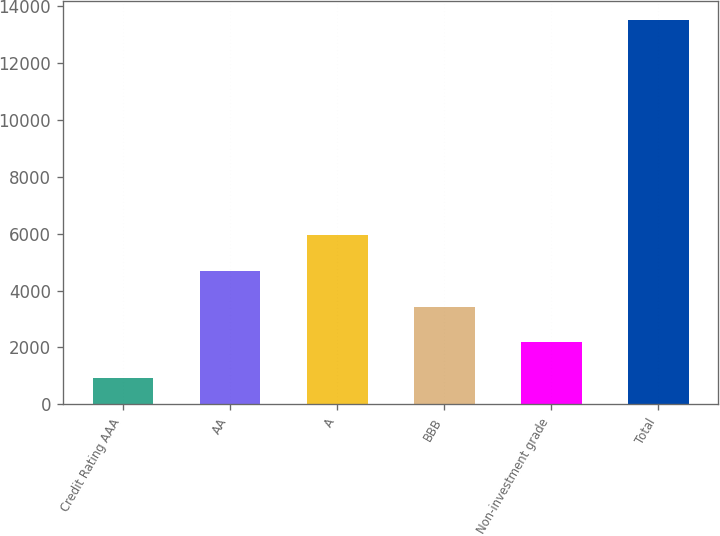<chart> <loc_0><loc_0><loc_500><loc_500><bar_chart><fcel>Credit Rating AAA<fcel>AA<fcel>A<fcel>BBB<fcel>Non-investment grade<fcel>Total<nl><fcel>918<fcel>4695.9<fcel>5955.2<fcel>3436.6<fcel>2177.3<fcel>13511<nl></chart> 